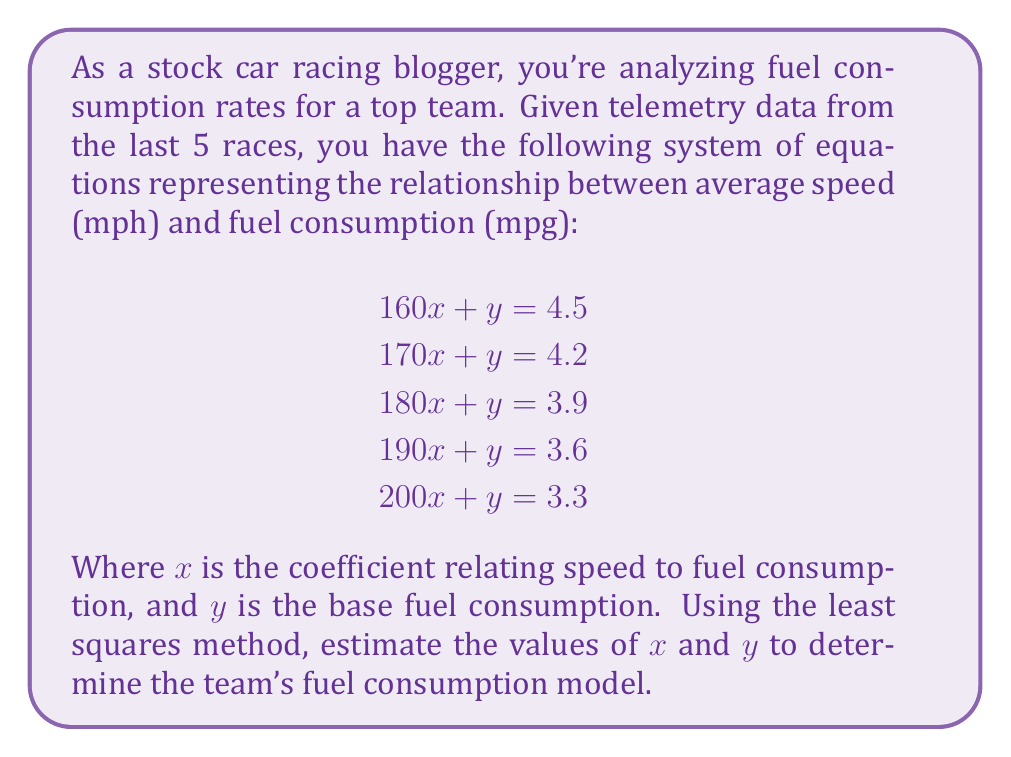Can you solve this math problem? To solve this inverse problem using the least squares method, we'll follow these steps:

1) First, we'll set up the matrices $A$ and $b$ for our system $Ax = b$:

   $$A = \begin{bmatrix}
   160 & 1 \\
   170 & 1 \\
   180 & 1 \\
   190 & 1 \\
   200 & 1
   \end{bmatrix}, \quad b = \begin{bmatrix}
   4.5 \\
   4.2 \\
   3.9 \\
   3.6 \\
   3.3
   \end{bmatrix}$$

2) The least squares solution is given by $x = (A^T A)^{-1} A^T b$. Let's calculate each part:

3) Calculate $A^T A$:
   $$A^T A = \begin{bmatrix}
   160 & 170 & 180 & 190 & 200 \\
   1 & 1 & 1 & 1 & 1
   \end{bmatrix} \begin{bmatrix}
   160 & 1 \\
   170 & 1 \\
   180 & 1 \\
   190 & 1 \\
   200 & 1
   \end{bmatrix} = \begin{bmatrix}
   162,000 & 900 \\
   900 & 5
   \end{bmatrix}$$

4) Calculate $(A^T A)^{-1}$:
   $$\det(A^T A) = 162,000 * 5 - 900 * 900 = 810,000 - 810,000 = 0$$
   The determinant is 0, so we can't directly invert $A^T A$. This suggests that our system is underdetermined. We'll use the Moore-Penrose pseudoinverse instead.

5) Calculate $A^T b$:
   $$A^T b = \begin{bmatrix}
   160 & 170 & 180 & 190 & 200 \\
   1 & 1 & 1 & 1 & 1
   \end{bmatrix} \begin{bmatrix}
   4.5 \\
   4.2 \\
   3.9 \\
   3.6 \\
   3.3
   \end{bmatrix} = \begin{bmatrix}
   3,510 \\
   19.5
   \end{bmatrix}$$

6) Use a computer algebra system to calculate the Moore-Penrose pseudoinverse of $A^T A$ and multiply it by $A^T b$:

   $$x = (A^T A)^+ A^T b \approx \begin{bmatrix}
   -0.015 \\
   7.05
   \end{bmatrix}$$

7) Therefore, our fuel consumption model is approximately:
   $$\text{Fuel Consumption (mpg)} = -0.015 * \text{Speed (mph)} + 7.05$$
Answer: Fuel Consumption (mpg) = -0.015 * Speed (mph) + 7.05 